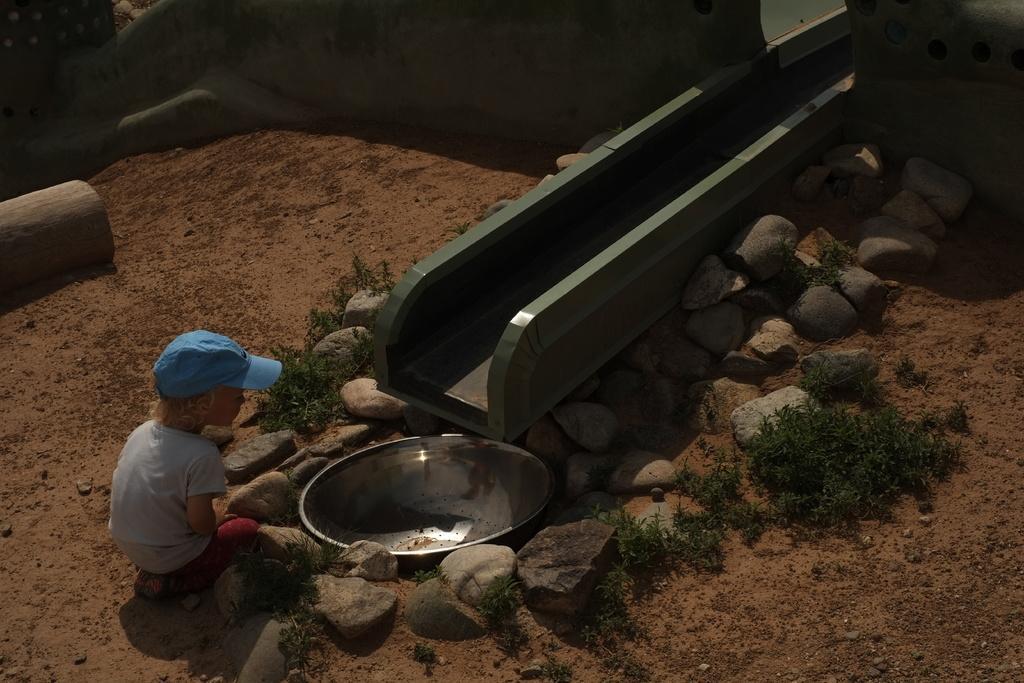How would you summarize this image in a sentence or two? In this image there is a kid. In front of him there is a bowl. Around the bowl there are rocks and plants. On top of the bowel there is a metal pipe. On the left side of the image there is a wooden log. 